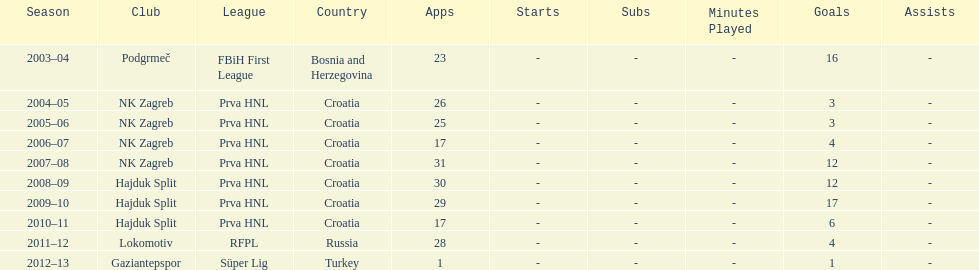Did ibricic score more or less goals in his 3 seasons with hajduk split when compared to his 4 seasons with nk zagreb? More. 